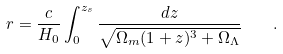Convert formula to latex. <formula><loc_0><loc_0><loc_500><loc_500>r = \frac { c } { H _ { 0 } } \int _ { 0 } ^ { z _ { s } } \frac { d z } { \sqrt { \Omega _ { m } ( 1 + z ) ^ { 3 } + \Omega _ { \Lambda } } } \quad .</formula> 